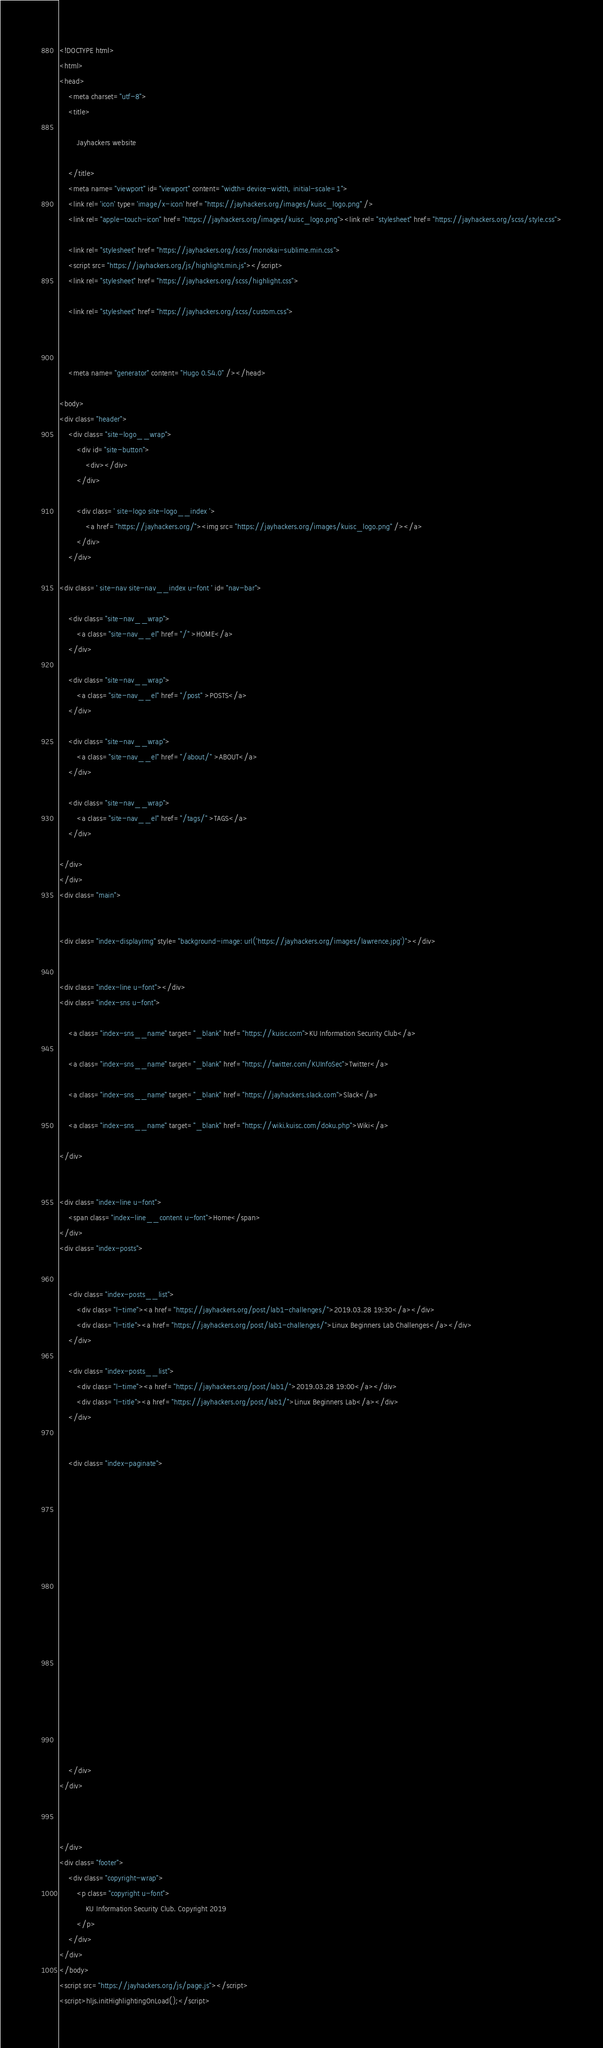<code> <loc_0><loc_0><loc_500><loc_500><_HTML_><!DOCTYPE html>
<html>
<head>
    <meta charset="utf-8">
    <title>
        
        Jayhackers website
        
    </title>
    <meta name="viewport" id="viewport" content="width=device-width, initial-scale=1">
    <link rel='icon' type='image/x-icon' href="https://jayhackers.org/images/kuisc_logo.png" />
    <link rel="apple-touch-icon" href="https://jayhackers.org/images/kuisc_logo.png"><link rel="stylesheet" href="https://jayhackers.org/scss/style.css">
    
    <link rel="stylesheet" href="https://jayhackers.org/scss/monokai-sublime.min.css">
    <script src="https://jayhackers.org/js/highlight.min.js"></script>
    <link rel="stylesheet" href="https://jayhackers.org/scss/highlight.css">
    
    <link rel="stylesheet" href="https://jayhackers.org/scss/custom.css">
    
    
    
    <meta name="generator" content="Hugo 0.54.0" /></head>

<body>
<div class="header">
    <div class="site-logo__wrap">
        <div id="site-button">
            <div></div>
        </div>
        
        <div class=' site-logo site-logo__index '>
            <a href="https://jayhackers.org/"><img src="https://jayhackers.org/images/kuisc_logo.png" /></a>
        </div>
    </div>
    
<div class=' site-nav site-nav__index u-font ' id="nav-bar">
    
    <div class="site-nav__wrap">
        <a class="site-nav__el" href="/" >HOME</a>
    </div>
    
    <div class="site-nav__wrap">
        <a class="site-nav__el" href="/post" >POSTS</a>
    </div>
    
    <div class="site-nav__wrap">
        <a class="site-nav__el" href="/about/" >ABOUT</a>
    </div>
    
    <div class="site-nav__wrap">
        <a class="site-nav__el" href="/tags/" >TAGS</a>
    </div>
    
</div>
</div>
<div class="main">


<div class="index-displayImg" style="background-image: url('https://jayhackers.org/images/lawrence.jpg')"></div>


<div class="index-line u-font"></div>
<div class="index-sns u-font">
    
    <a class="index-sns__name" target="_blank" href="https://kuisc.com">KU Information Security Club</a>
    
    <a class="index-sns__name" target="_blank" href="https://twitter.com/KUInfoSec">Twitter</a>
    
    <a class="index-sns__name" target="_blank" href="https://jayhackers.slack.com">Slack</a>
    
    <a class="index-sns__name" target="_blank" href="https://wiki.kuisc.com/doku.php">Wiki</a>
    
</div>


<div class="index-line u-font">
    <span class="index-line__content u-font">Home</span>
</div>
<div class="index-posts">
    
    
    <div class="index-posts__list">
        <div class="l-time"><a href="https://jayhackers.org/post/lab1-challenges/">2019.03.28 19:30</a></div>
        <div class="l-title"><a href="https://jayhackers.org/post/lab1-challenges/">Linux Beginners Lab Challenges</a></div>
    </div>
    
    <div class="index-posts__list">
        <div class="l-time"><a href="https://jayhackers.org/post/lab1/">2019.03.28 19:00</a></div>
        <div class="l-title"><a href="https://jayhackers.org/post/lab1/">Linux Beginners Lab</a></div>
    </div>
    

    <div class="index-paginate">
        


















    </div>
</div>



</div>
<div class="footer">
    <div class="copyright-wrap">
        <p class="copyright u-font">
            KU Information Security Club. Copyright 2019
        </p>
    </div>
</div>
</body>
<script src="https://jayhackers.org/js/page.js"></script>
<script>hljs.initHighlightingOnLoad();</script>
</code> 